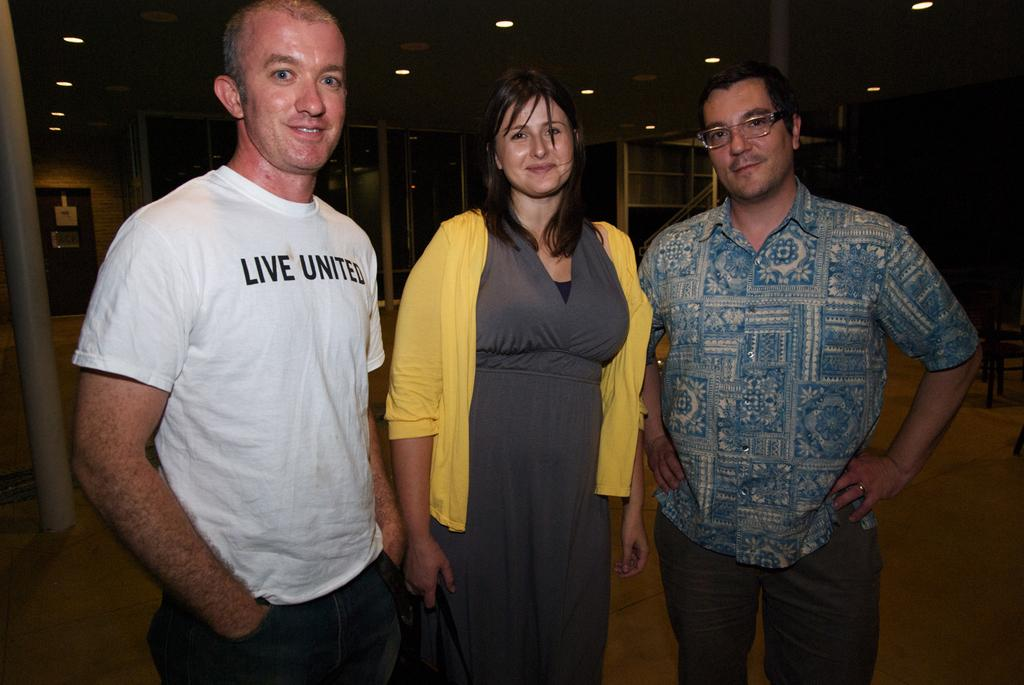What are the people in the image doing? The people in the image are standing on the floor. What can be seen in the background of the image? There are racks visible in the background of the image. What architectural feature is present in the image? There is a door in the image. What is on the roof in the image? There are lights on the roof in the image. What type of square is being discussed in the image? There is no square present in the image; it features people standing on the floor, racks in the background, a door, and lights on the roof. 